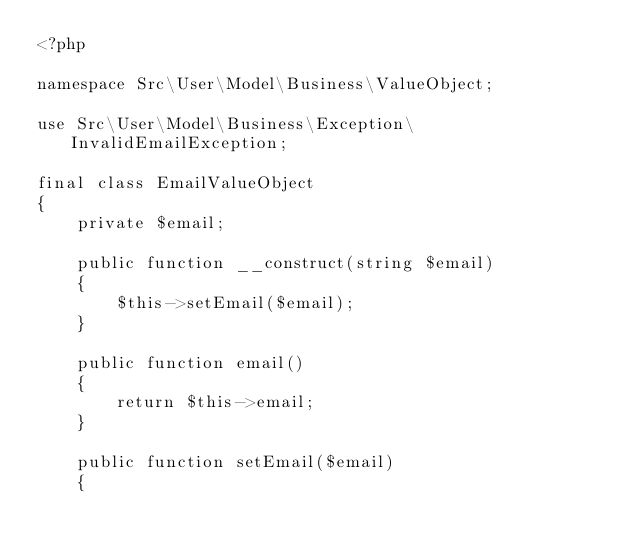Convert code to text. <code><loc_0><loc_0><loc_500><loc_500><_PHP_><?php

namespace Src\User\Model\Business\ValueObject;

use Src\User\Model\Business\Exception\InvalidEmailException;

final class EmailValueObject
{
    private $email;
    
    public function __construct(string $email)
    {
        $this->setEmail($email);
    }

    public function email()
    {
        return $this->email;
    }

    public function setEmail($email)
    {</code> 